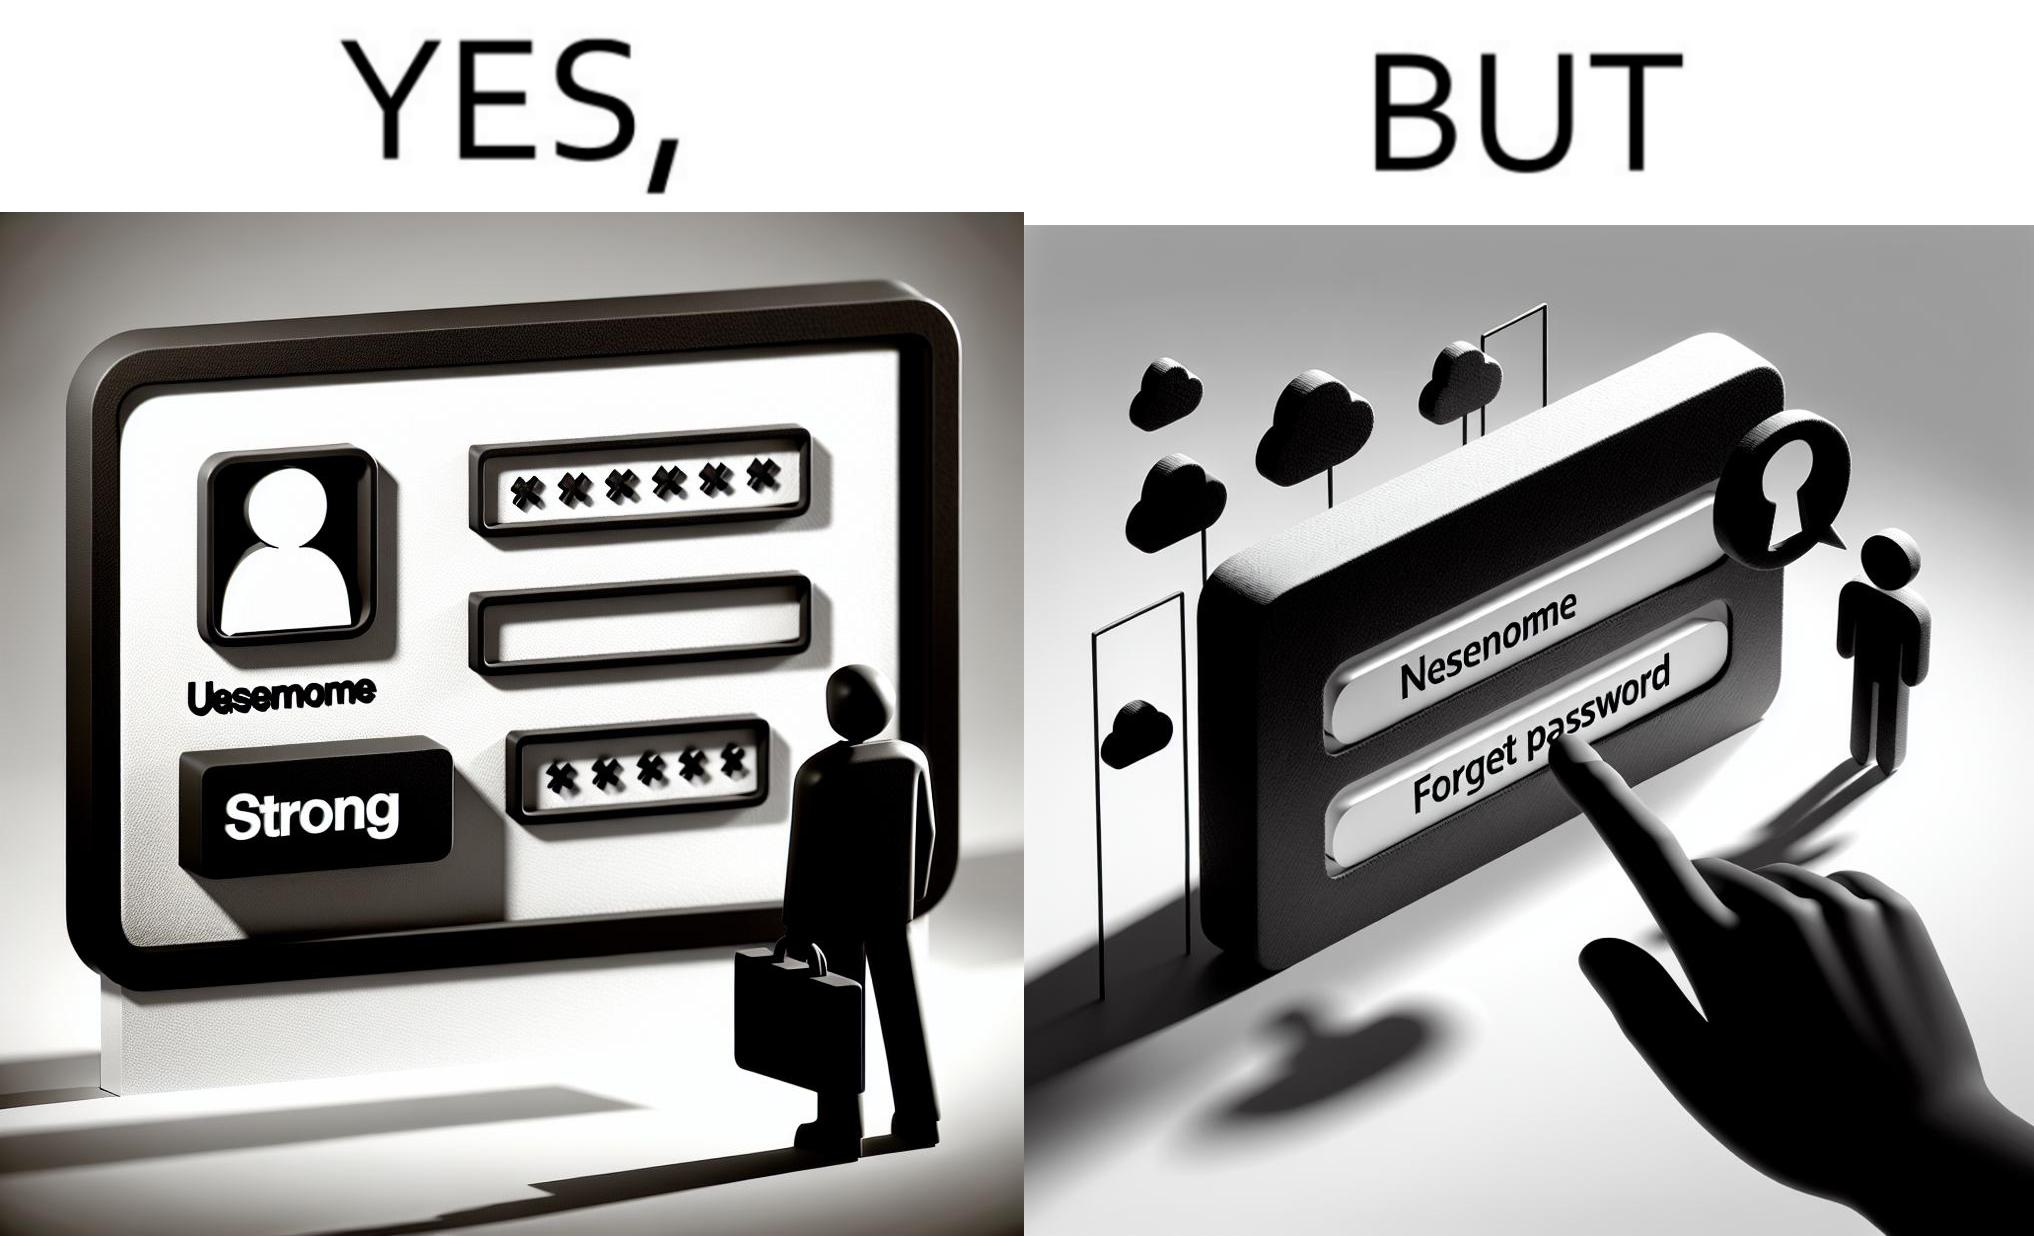Explain why this image is satirical. The image is ironic, because people set such a strong passwords for their accounts that they even forget the password and need to reset them 